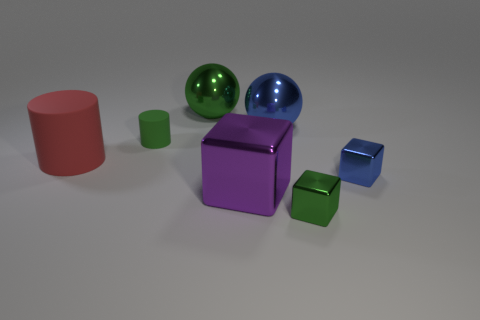What is the shape of the large shiny thing that is the same color as the tiny matte cylinder?
Give a very brief answer. Sphere. Is the small matte cylinder the same color as the large metal block?
Your response must be concise. No. How many balls are either red rubber objects or small green rubber objects?
Offer a very short reply. 0. What material is the large object that is both on the right side of the large matte object and left of the large purple thing?
Give a very brief answer. Metal. There is a large purple cube; how many red cylinders are left of it?
Provide a succinct answer. 1. Do the small cube that is behind the big block and the cylinder that is in front of the tiny cylinder have the same material?
Your answer should be very brief. No. What number of objects are large balls that are right of the green metal sphere or tiny green rubber things?
Offer a very short reply. 2. Are there fewer large purple shiny blocks that are on the right side of the big red thing than big purple blocks in front of the big blue metal thing?
Keep it short and to the point. No. How many other objects are the same size as the green cube?
Your answer should be very brief. 2. Is the material of the small green cylinder the same as the ball that is to the left of the large purple block?
Offer a terse response. No. 